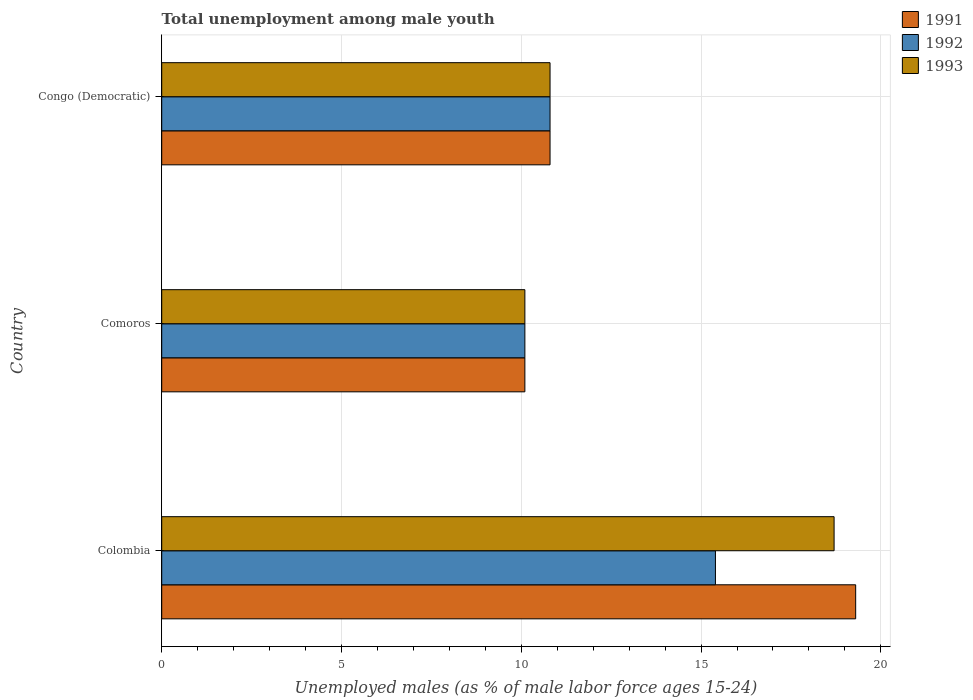How many bars are there on the 1st tick from the top?
Provide a short and direct response. 3. How many bars are there on the 3rd tick from the bottom?
Provide a succinct answer. 3. In how many cases, is the number of bars for a given country not equal to the number of legend labels?
Your response must be concise. 0. What is the percentage of unemployed males in in 1993 in Comoros?
Ensure brevity in your answer.  10.1. Across all countries, what is the maximum percentage of unemployed males in in 1992?
Your answer should be very brief. 15.4. Across all countries, what is the minimum percentage of unemployed males in in 1992?
Offer a terse response. 10.1. In which country was the percentage of unemployed males in in 1993 minimum?
Your answer should be very brief. Comoros. What is the total percentage of unemployed males in in 1992 in the graph?
Ensure brevity in your answer.  36.3. What is the difference between the percentage of unemployed males in in 1992 in Colombia and that in Congo (Democratic)?
Provide a succinct answer. 4.6. What is the difference between the percentage of unemployed males in in 1993 in Congo (Democratic) and the percentage of unemployed males in in 1991 in Colombia?
Offer a very short reply. -8.5. What is the average percentage of unemployed males in in 1992 per country?
Your answer should be very brief. 12.1. In how many countries, is the percentage of unemployed males in in 1991 greater than 9 %?
Offer a very short reply. 3. What is the ratio of the percentage of unemployed males in in 1993 in Colombia to that in Comoros?
Offer a terse response. 1.85. Is the percentage of unemployed males in in 1992 in Colombia less than that in Comoros?
Keep it short and to the point. No. Is the difference between the percentage of unemployed males in in 1991 in Colombia and Comoros greater than the difference between the percentage of unemployed males in in 1992 in Colombia and Comoros?
Your response must be concise. Yes. What is the difference between the highest and the second highest percentage of unemployed males in in 1993?
Keep it short and to the point. 7.9. What is the difference between the highest and the lowest percentage of unemployed males in in 1993?
Provide a succinct answer. 8.6. In how many countries, is the percentage of unemployed males in in 1991 greater than the average percentage of unemployed males in in 1991 taken over all countries?
Offer a terse response. 1. How many bars are there?
Your response must be concise. 9. Does the graph contain any zero values?
Offer a very short reply. No. Does the graph contain grids?
Provide a short and direct response. Yes. Where does the legend appear in the graph?
Your answer should be very brief. Top right. What is the title of the graph?
Ensure brevity in your answer.  Total unemployment among male youth. Does "1967" appear as one of the legend labels in the graph?
Your answer should be compact. No. What is the label or title of the X-axis?
Offer a terse response. Unemployed males (as % of male labor force ages 15-24). What is the label or title of the Y-axis?
Provide a short and direct response. Country. What is the Unemployed males (as % of male labor force ages 15-24) in 1991 in Colombia?
Make the answer very short. 19.3. What is the Unemployed males (as % of male labor force ages 15-24) of 1992 in Colombia?
Provide a succinct answer. 15.4. What is the Unemployed males (as % of male labor force ages 15-24) of 1993 in Colombia?
Ensure brevity in your answer.  18.7. What is the Unemployed males (as % of male labor force ages 15-24) in 1991 in Comoros?
Your answer should be very brief. 10.1. What is the Unemployed males (as % of male labor force ages 15-24) in 1992 in Comoros?
Ensure brevity in your answer.  10.1. What is the Unemployed males (as % of male labor force ages 15-24) of 1993 in Comoros?
Your response must be concise. 10.1. What is the Unemployed males (as % of male labor force ages 15-24) in 1991 in Congo (Democratic)?
Offer a terse response. 10.8. What is the Unemployed males (as % of male labor force ages 15-24) in 1992 in Congo (Democratic)?
Give a very brief answer. 10.8. What is the Unemployed males (as % of male labor force ages 15-24) in 1993 in Congo (Democratic)?
Make the answer very short. 10.8. Across all countries, what is the maximum Unemployed males (as % of male labor force ages 15-24) of 1991?
Offer a very short reply. 19.3. Across all countries, what is the maximum Unemployed males (as % of male labor force ages 15-24) of 1992?
Provide a succinct answer. 15.4. Across all countries, what is the maximum Unemployed males (as % of male labor force ages 15-24) of 1993?
Ensure brevity in your answer.  18.7. Across all countries, what is the minimum Unemployed males (as % of male labor force ages 15-24) in 1991?
Your answer should be compact. 10.1. Across all countries, what is the minimum Unemployed males (as % of male labor force ages 15-24) of 1992?
Your answer should be compact. 10.1. Across all countries, what is the minimum Unemployed males (as % of male labor force ages 15-24) in 1993?
Your answer should be very brief. 10.1. What is the total Unemployed males (as % of male labor force ages 15-24) of 1991 in the graph?
Offer a very short reply. 40.2. What is the total Unemployed males (as % of male labor force ages 15-24) of 1992 in the graph?
Your response must be concise. 36.3. What is the total Unemployed males (as % of male labor force ages 15-24) in 1993 in the graph?
Give a very brief answer. 39.6. What is the difference between the Unemployed males (as % of male labor force ages 15-24) in 1992 in Comoros and that in Congo (Democratic)?
Give a very brief answer. -0.7. What is the difference between the Unemployed males (as % of male labor force ages 15-24) of 1993 in Comoros and that in Congo (Democratic)?
Provide a short and direct response. -0.7. What is the difference between the Unemployed males (as % of male labor force ages 15-24) in 1991 in Colombia and the Unemployed males (as % of male labor force ages 15-24) in 1992 in Comoros?
Your answer should be very brief. 9.2. What is the difference between the Unemployed males (as % of male labor force ages 15-24) of 1991 in Colombia and the Unemployed males (as % of male labor force ages 15-24) of 1993 in Comoros?
Give a very brief answer. 9.2. What is the difference between the Unemployed males (as % of male labor force ages 15-24) in 1992 in Colombia and the Unemployed males (as % of male labor force ages 15-24) in 1993 in Comoros?
Offer a terse response. 5.3. What is the difference between the Unemployed males (as % of male labor force ages 15-24) of 1991 in Colombia and the Unemployed males (as % of male labor force ages 15-24) of 1992 in Congo (Democratic)?
Ensure brevity in your answer.  8.5. What is the difference between the Unemployed males (as % of male labor force ages 15-24) in 1991 in Colombia and the Unemployed males (as % of male labor force ages 15-24) in 1993 in Congo (Democratic)?
Your response must be concise. 8.5. What is the difference between the Unemployed males (as % of male labor force ages 15-24) of 1992 in Colombia and the Unemployed males (as % of male labor force ages 15-24) of 1993 in Congo (Democratic)?
Your answer should be compact. 4.6. What is the difference between the Unemployed males (as % of male labor force ages 15-24) in 1991 in Comoros and the Unemployed males (as % of male labor force ages 15-24) in 1992 in Congo (Democratic)?
Your response must be concise. -0.7. What is the average Unemployed males (as % of male labor force ages 15-24) in 1992 per country?
Keep it short and to the point. 12.1. What is the difference between the Unemployed males (as % of male labor force ages 15-24) in 1991 and Unemployed males (as % of male labor force ages 15-24) in 1992 in Colombia?
Offer a terse response. 3.9. What is the difference between the Unemployed males (as % of male labor force ages 15-24) of 1992 and Unemployed males (as % of male labor force ages 15-24) of 1993 in Colombia?
Provide a short and direct response. -3.3. What is the difference between the Unemployed males (as % of male labor force ages 15-24) in 1992 and Unemployed males (as % of male labor force ages 15-24) in 1993 in Comoros?
Ensure brevity in your answer.  0. What is the difference between the Unemployed males (as % of male labor force ages 15-24) in 1991 and Unemployed males (as % of male labor force ages 15-24) in 1993 in Congo (Democratic)?
Your response must be concise. 0. What is the ratio of the Unemployed males (as % of male labor force ages 15-24) of 1991 in Colombia to that in Comoros?
Offer a terse response. 1.91. What is the ratio of the Unemployed males (as % of male labor force ages 15-24) of 1992 in Colombia to that in Comoros?
Provide a succinct answer. 1.52. What is the ratio of the Unemployed males (as % of male labor force ages 15-24) in 1993 in Colombia to that in Comoros?
Your answer should be very brief. 1.85. What is the ratio of the Unemployed males (as % of male labor force ages 15-24) of 1991 in Colombia to that in Congo (Democratic)?
Your response must be concise. 1.79. What is the ratio of the Unemployed males (as % of male labor force ages 15-24) in 1992 in Colombia to that in Congo (Democratic)?
Keep it short and to the point. 1.43. What is the ratio of the Unemployed males (as % of male labor force ages 15-24) in 1993 in Colombia to that in Congo (Democratic)?
Your response must be concise. 1.73. What is the ratio of the Unemployed males (as % of male labor force ages 15-24) in 1991 in Comoros to that in Congo (Democratic)?
Ensure brevity in your answer.  0.94. What is the ratio of the Unemployed males (as % of male labor force ages 15-24) in 1992 in Comoros to that in Congo (Democratic)?
Ensure brevity in your answer.  0.94. What is the ratio of the Unemployed males (as % of male labor force ages 15-24) of 1993 in Comoros to that in Congo (Democratic)?
Make the answer very short. 0.94. What is the difference between the highest and the second highest Unemployed males (as % of male labor force ages 15-24) in 1991?
Ensure brevity in your answer.  8.5. What is the difference between the highest and the lowest Unemployed males (as % of male labor force ages 15-24) in 1991?
Make the answer very short. 9.2. What is the difference between the highest and the lowest Unemployed males (as % of male labor force ages 15-24) in 1992?
Give a very brief answer. 5.3. What is the difference between the highest and the lowest Unemployed males (as % of male labor force ages 15-24) in 1993?
Give a very brief answer. 8.6. 